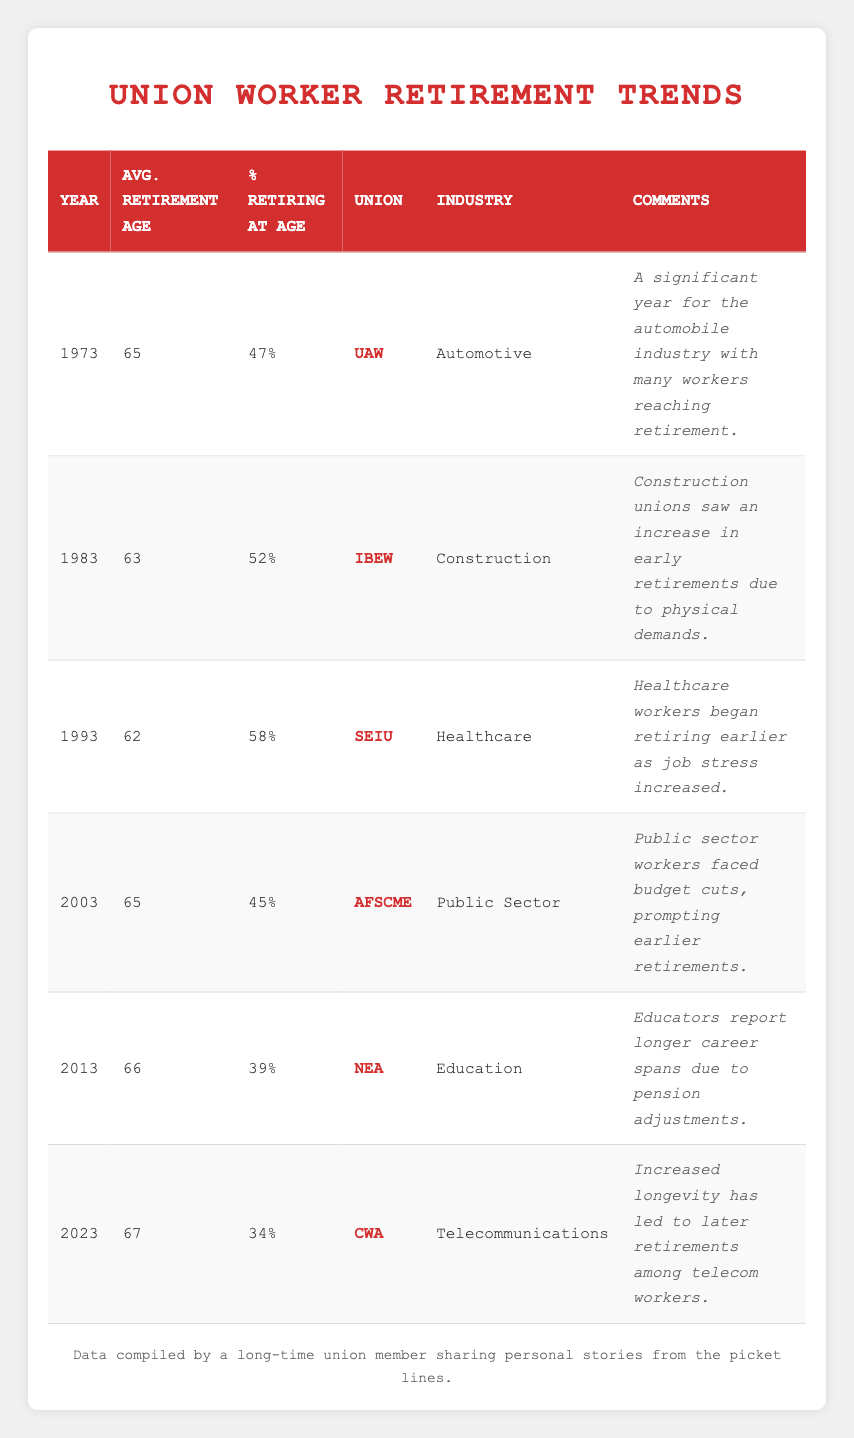What was the average retirement age for union workers in 1983? The table shows that in 1983, the average retirement age for union workers was listed as 63.
Answer: 63 Which union had the highest percentage of workers retiring at age 62? According to the table, in 1993, SEIU had the highest percentage of union workers retiring at age 62, which was 58%.
Answer: 58% Was the average retirement age lower in 1993 than in 2003? In 1993, the average retirement age was 62, while in 2003 it was 65. Therefore, the average retirement age was not lower in 2003.
Answer: No What is the difference in retirement age between union workers in 1973 and 2023? The table indicates that the average retirement age was 65 in 1973 and 67 in 2023. The difference is 67 - 65 = 2 years.
Answer: 2 years What percentage of union workers retired at age 66 in 2013? The table indicates that in 2013, the average retirement age was 66, with 39% of union workers retiring at that age.
Answer: 39% Which industry and union had the lowest average retirement age, and what was that age? Looking through the table, SEIU from the healthcare industry had the lowest average retirement age at 62 in 1993.
Answer: SEIU, Healthcare, 62 How has the percentage of union workers retiring at age changed from 2003 to 2023? In 2003, the percentage of workers retiring at age was 45%, and by 2023, that percentage decreased to 34%. The change is a decrease of 11%.
Answer: Decreased by 11% What trend can be observed about the average retirement age over the years from 1973 to 2023? Reviewing the table, the average retirement age shows a slight increase over the years, going from 65 in 1973 to 67 in 2023, despite fluctuations in some years.
Answer: Slight increase 